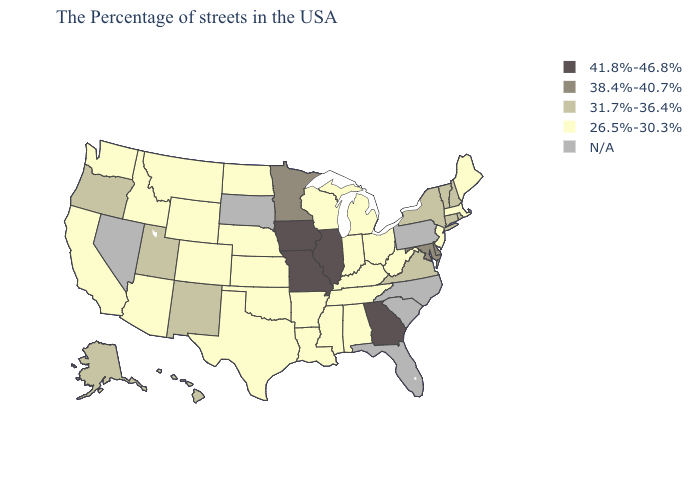Name the states that have a value in the range N/A?
Be succinct. Pennsylvania, North Carolina, South Carolina, Florida, South Dakota, Nevada. What is the lowest value in the West?
Keep it brief. 26.5%-30.3%. Name the states that have a value in the range 31.7%-36.4%?
Be succinct. Rhode Island, New Hampshire, Vermont, Connecticut, New York, Virginia, New Mexico, Utah, Oregon, Alaska, Hawaii. How many symbols are there in the legend?
Write a very short answer. 5. Does Illinois have the lowest value in the MidWest?
Concise answer only. No. Does the first symbol in the legend represent the smallest category?
Be succinct. No. What is the value of Hawaii?
Short answer required. 31.7%-36.4%. Does the map have missing data?
Write a very short answer. Yes. Name the states that have a value in the range 41.8%-46.8%?
Quick response, please. Georgia, Illinois, Missouri, Iowa. Does the map have missing data?
Quick response, please. Yes. Which states hav the highest value in the South?
Answer briefly. Georgia. Does the first symbol in the legend represent the smallest category?
Give a very brief answer. No. Name the states that have a value in the range N/A?
Concise answer only. Pennsylvania, North Carolina, South Carolina, Florida, South Dakota, Nevada. What is the value of Montana?
Give a very brief answer. 26.5%-30.3%. 